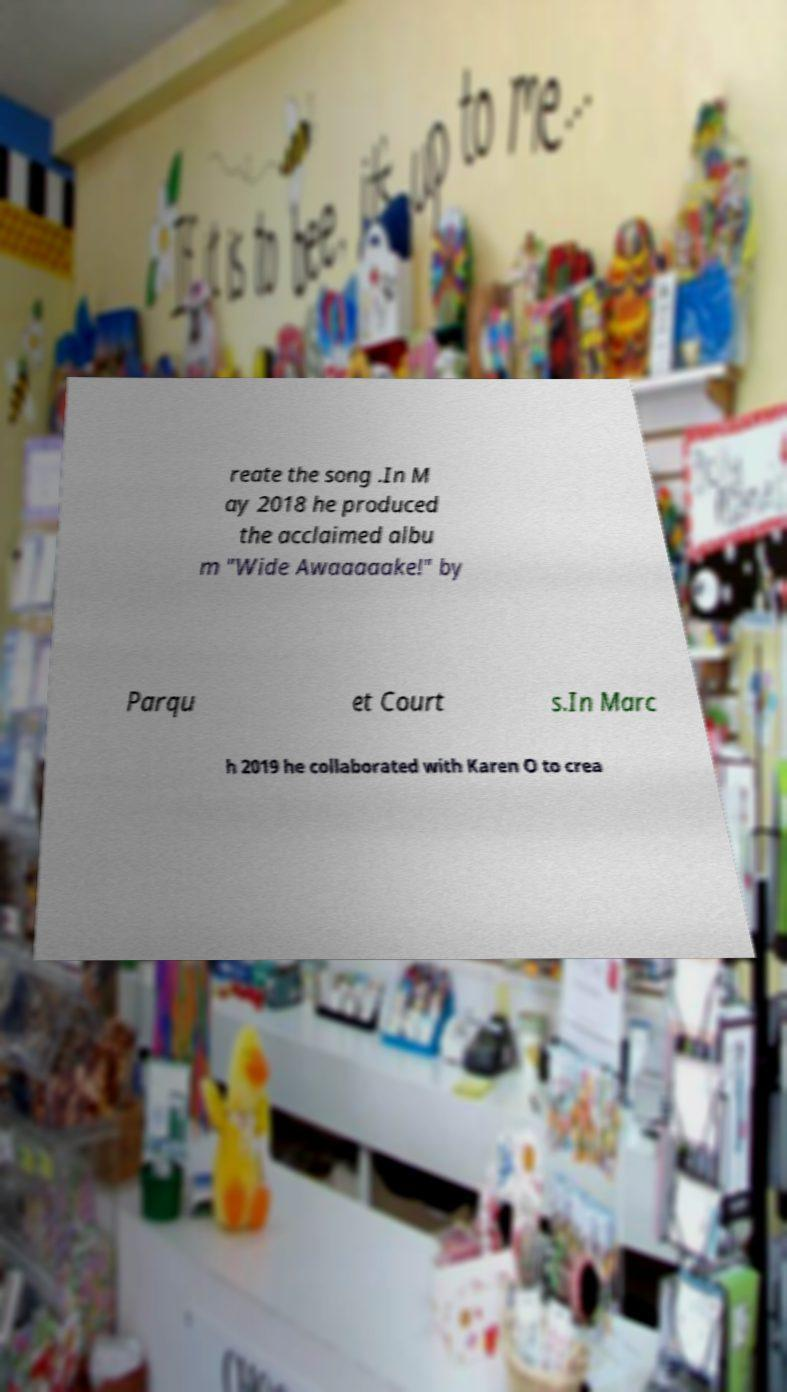Can you accurately transcribe the text from the provided image for me? reate the song .In M ay 2018 he produced the acclaimed albu m "Wide Awaaaaake!" by Parqu et Court s.In Marc h 2019 he collaborated with Karen O to crea 